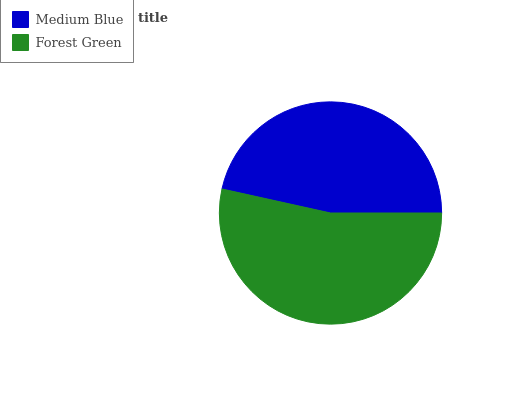Is Medium Blue the minimum?
Answer yes or no. Yes. Is Forest Green the maximum?
Answer yes or no. Yes. Is Forest Green the minimum?
Answer yes or no. No. Is Forest Green greater than Medium Blue?
Answer yes or no. Yes. Is Medium Blue less than Forest Green?
Answer yes or no. Yes. Is Medium Blue greater than Forest Green?
Answer yes or no. No. Is Forest Green less than Medium Blue?
Answer yes or no. No. Is Forest Green the high median?
Answer yes or no. Yes. Is Medium Blue the low median?
Answer yes or no. Yes. Is Medium Blue the high median?
Answer yes or no. No. Is Forest Green the low median?
Answer yes or no. No. 